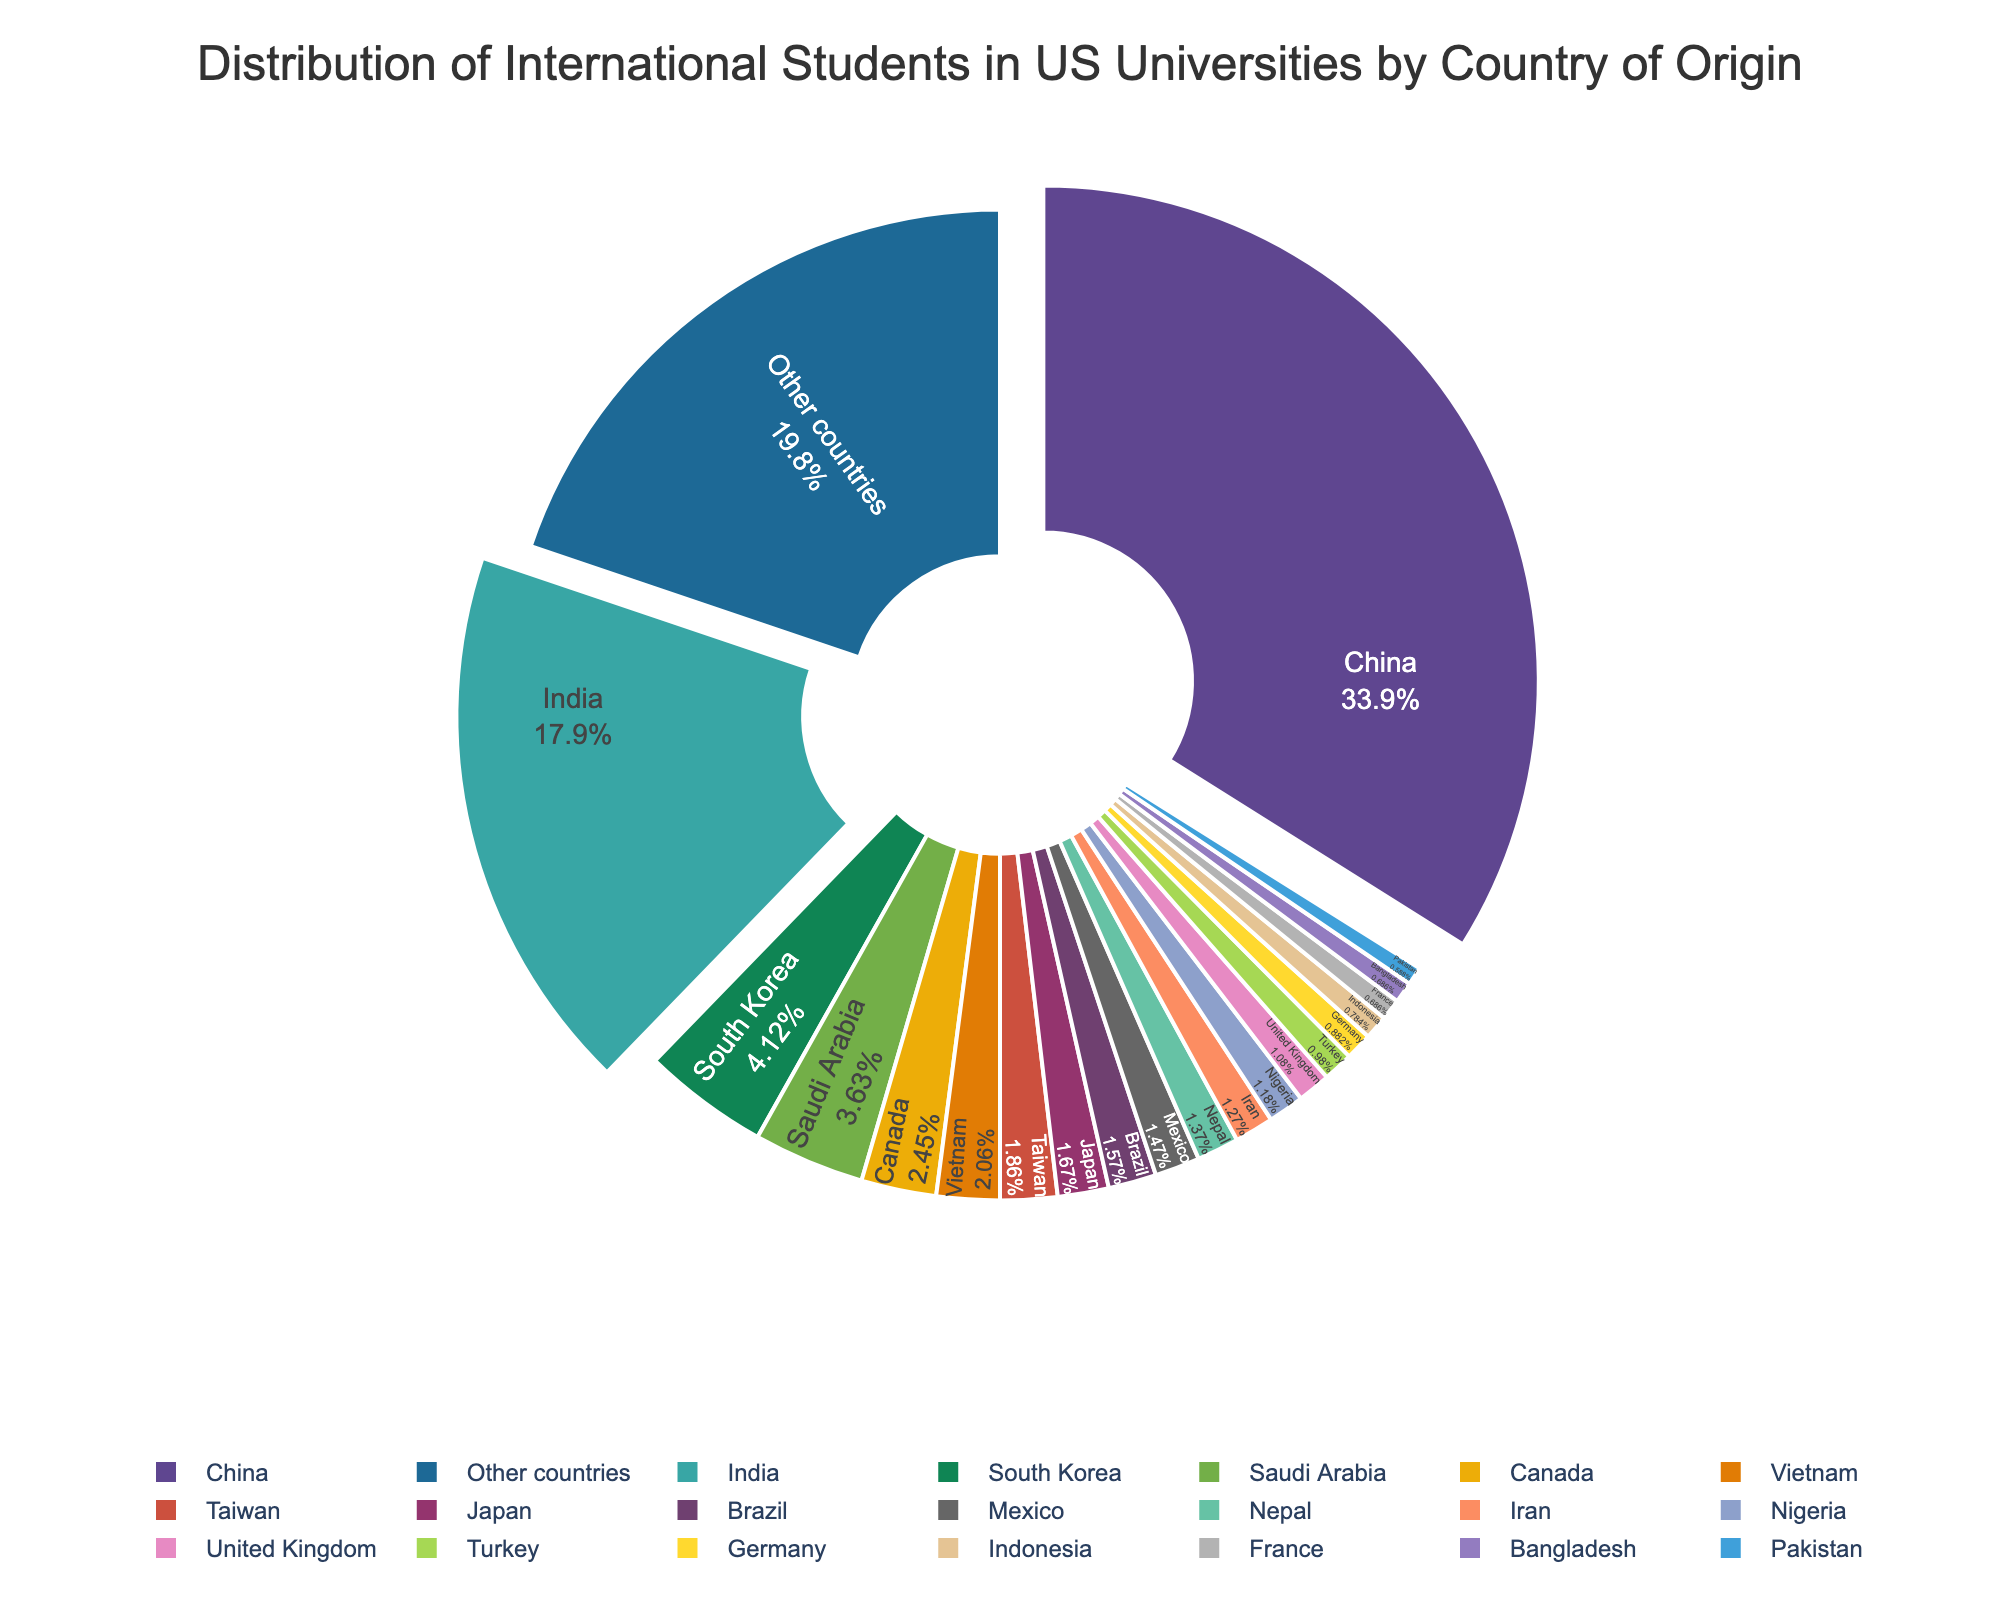What's the percentage of international students from China? The percentage of international students from China is directly shown on the pie chart.
Answer: 34.6% How many countries have a smaller percentage of international students than South Korea? First identify South Korea's percentage (4.2%), and then count the countries with smaller percentages on the pie chart. There are 17 countries.
Answer: 17 Which two countries have the largest percentages of international students? The pie chart shows China and India have the largest percentages, with 34.6% and 18.3% respectively. Identify these percentages in the chart.
Answer: China and India What's the combined percentage of international students from Saudi Arabia, Canada, and Vietnam? Add the percentages: 3.7% (Saudi Arabia) + 2.5% (Canada) + 2.1% (Vietnam). This sums up to 8.3%.
Answer: 8.3% How does the percentage of international students from India compare to that from China? According to the pie chart, India has 18.3% while China has 34.6%. India's percentage is less than China’s.
Answer: India has fewer students than China What color represents students from Brazil on the pie chart? Examine the pie chart and locate Brazil's segment. The color of this segment is identified visually. In the provided example code, Brazil is likely represented by a distinct color such as one from the custom color palette.
Answer: Specific color (depends on the palette) If you combine the percentages of students from the UK, Turkey, and Germany, is the total higher or lower than that of students from South Korea? Sum UK (1.1%), Turkey (1.0%), and Germany (0.9%) which equals 3.0%. South Korea's percentage is 4.2%. 3.0% is lower than 4.2%.
Answer: Lower What is the total percentage of international students from countries with a percentage less than 2%? Sum up the percentages for Taiwan, Japan, Brazil, Mexico, Nepal, Iran, Nigeria, United Kingdom, Turkey, Germany, Indonesia, France, Bangladesh, and Pakistan. The total is 1.9+1.7+1.6+1.5+1.4+1.3+1.2+1.1+1.0+0.9+0.8+0.7+0.7+0.6 = 17.4%.
Answer: 17.4% What is the difference between the percentage of international students from India and Saudi Arabia? Subtract Saudi Arabia's percentage (3.7%) from India's percentage (18.3%): 18.3 - 3.7 = 14.6%.
Answer: 14.6% Are there more international students from Other countries collectively, or from China and India combined? China and India combined is 34.6% + 18.3% = 52.9%. Other countries make up 20.2%. 52.9% is greater than 20.2%.
Answer: China and India combined 